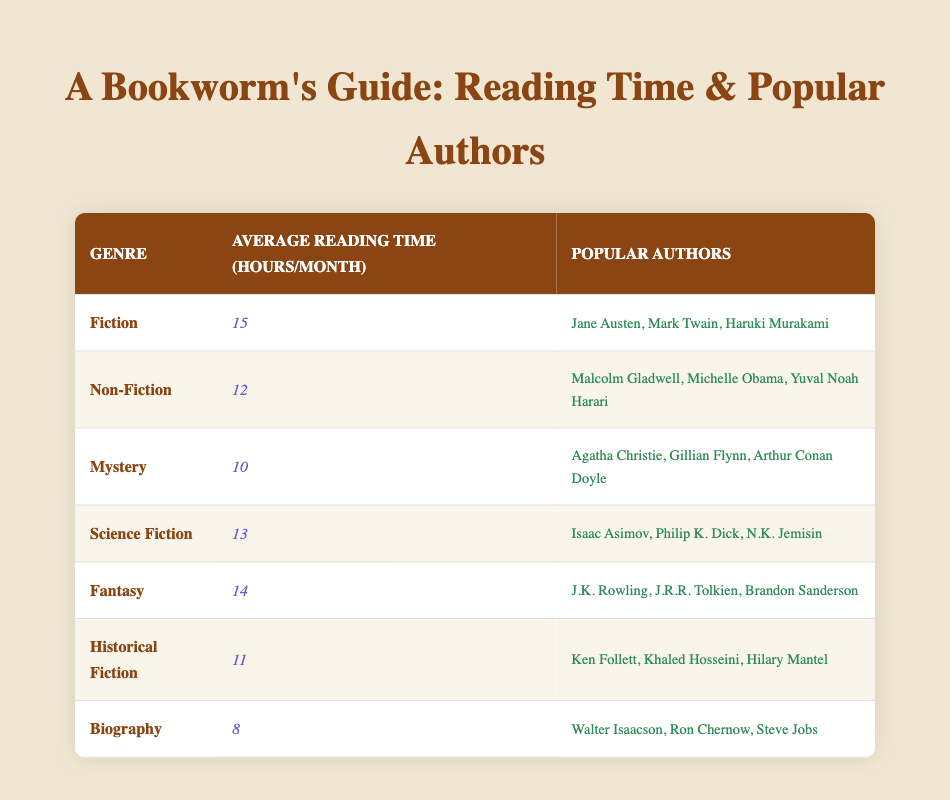What is the average reading time for the Mystery genre? The table indicates that the average reading time for the Mystery genre is 10 hours per month.
Answer: 10 hours How many popular authors are listed for the Science Fiction genre? There are three popular authors listed for the Science Fiction genre: Isaac Asimov, Philip K. Dick, and N.K. Jemisin.
Answer: 3 authors Which genre has the highest average reading time? By comparing the average reading times, Fiction has the highest average at 15 hours per month.
Answer: Fiction What is the total average reading time for Fantasy and Science Fiction combined? The average for Fantasy is 14 hours and for Science Fiction is 13 hours. Adding them together gives 14 + 13 = 27 hours.
Answer: 27 hours Is it true that Biography genre has the same average reading time as Historical Fiction? Yes, it's false because the Biography genre has an average reading time of 8 hours, while Historical Fiction has 11 hours, so they are different.
Answer: No What is the difference in average reading time between Fiction and Biography? The average reading time for Fiction is 15 hours and for Biography is 8 hours. The difference is 15 - 8 = 7 hours.
Answer: 7 hours Which genre has a lower average reading time, Historical Fiction or Non-Fiction? Historical Fiction has an average of 11 hours, while Non-Fiction has 12 hours. Therefore, Historical Fiction has a lower average reading time.
Answer: Historical Fiction How many genres have an average reading time of 12 hours or more? The genres with 12 hours or more are Fiction (15), Non-Fiction (12), Science Fiction (13), Fantasy (14), and Historical Fiction (11). This counts to a total of 5 genres.
Answer: 5 genres What is the average reading time across all genres? The average reading times are 15, 12, 10, 13, 14, 11, and 8 hours. Adding them gives 15 + 12 + 10 + 13 + 14 + 11 + 8 = 93 hours. Dividing by 7 (number of genres) gives 93 / 7 = 13.29 (approx).
Answer: 13.29 hours 